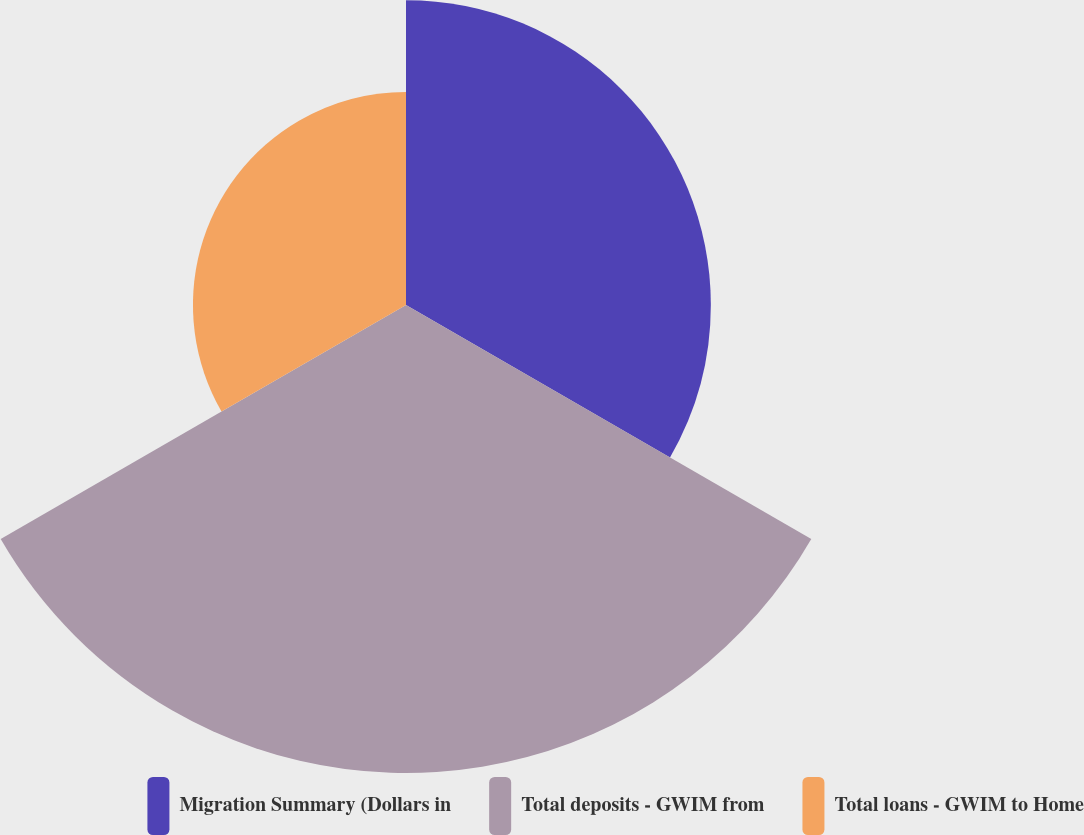<chart> <loc_0><loc_0><loc_500><loc_500><pie_chart><fcel>Migration Summary (Dollars in<fcel>Total deposits - GWIM from<fcel>Total loans - GWIM to Home<nl><fcel>30.92%<fcel>47.47%<fcel>21.61%<nl></chart> 